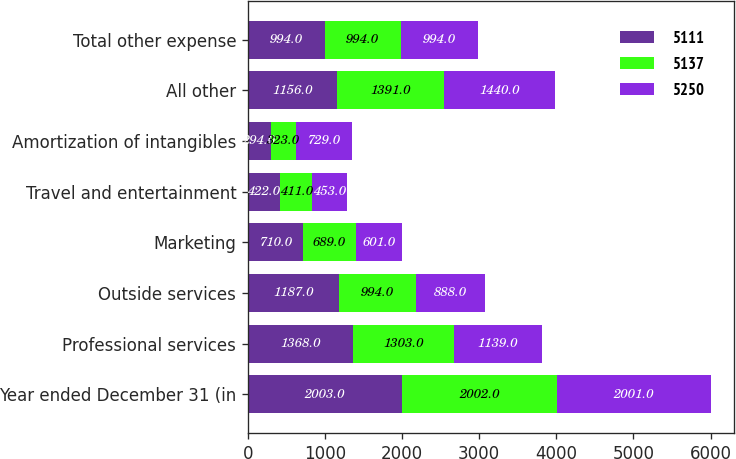<chart> <loc_0><loc_0><loc_500><loc_500><stacked_bar_chart><ecel><fcel>Year ended December 31 (in<fcel>Professional services<fcel>Outside services<fcel>Marketing<fcel>Travel and entertainment<fcel>Amortization of intangibles<fcel>All other<fcel>Total other expense<nl><fcel>5111<fcel>2003<fcel>1368<fcel>1187<fcel>710<fcel>422<fcel>294<fcel>1156<fcel>994<nl><fcel>5137<fcel>2002<fcel>1303<fcel>994<fcel>689<fcel>411<fcel>323<fcel>1391<fcel>994<nl><fcel>5250<fcel>2001<fcel>1139<fcel>888<fcel>601<fcel>453<fcel>729<fcel>1440<fcel>994<nl></chart> 